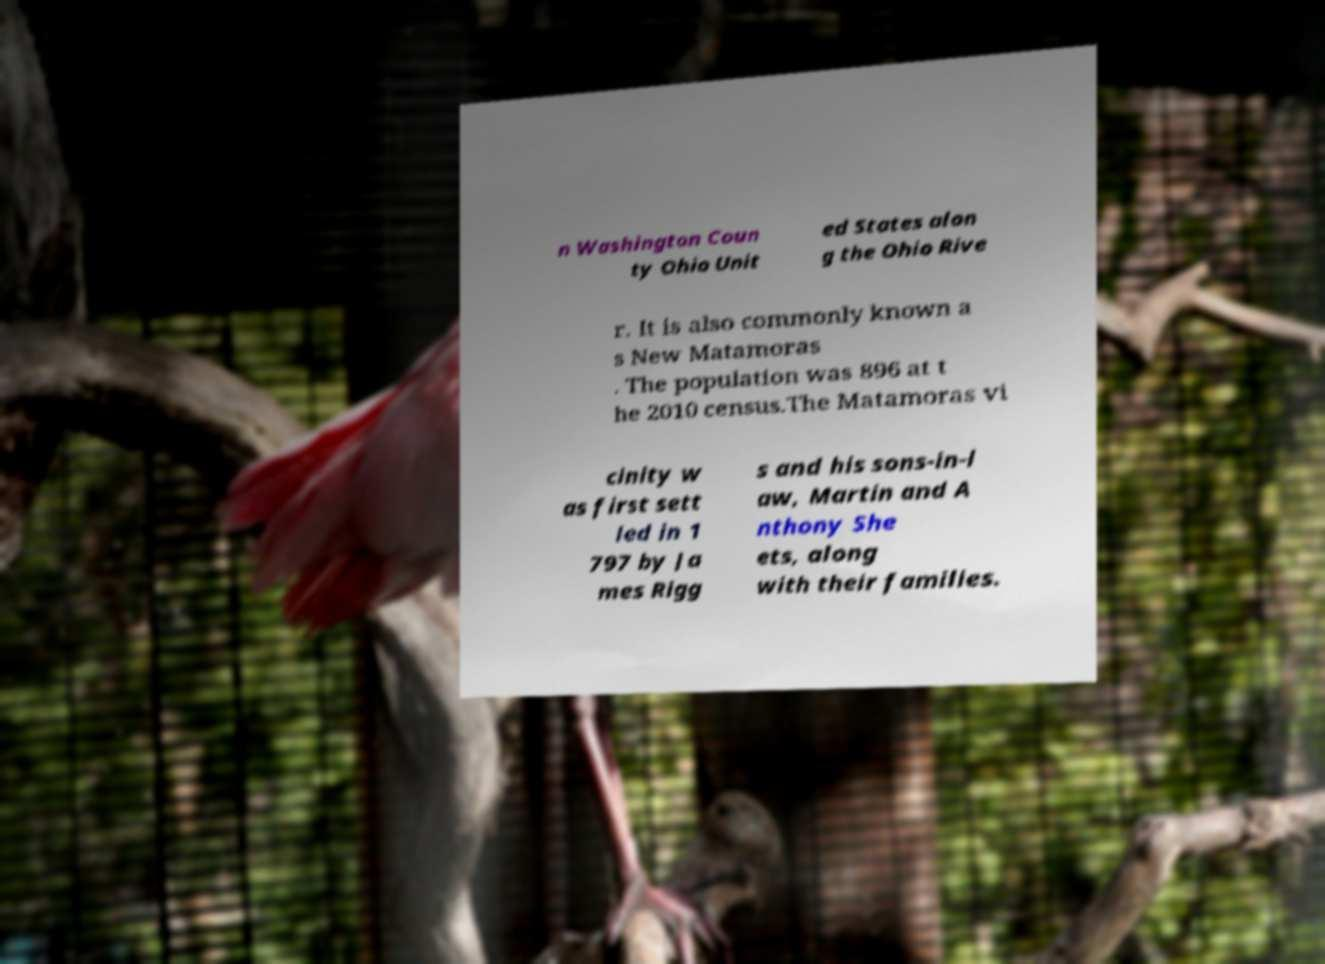For documentation purposes, I need the text within this image transcribed. Could you provide that? n Washington Coun ty Ohio Unit ed States alon g the Ohio Rive r. It is also commonly known a s New Matamoras . The population was 896 at t he 2010 census.The Matamoras vi cinity w as first sett led in 1 797 by Ja mes Rigg s and his sons-in-l aw, Martin and A nthony She ets, along with their families. 